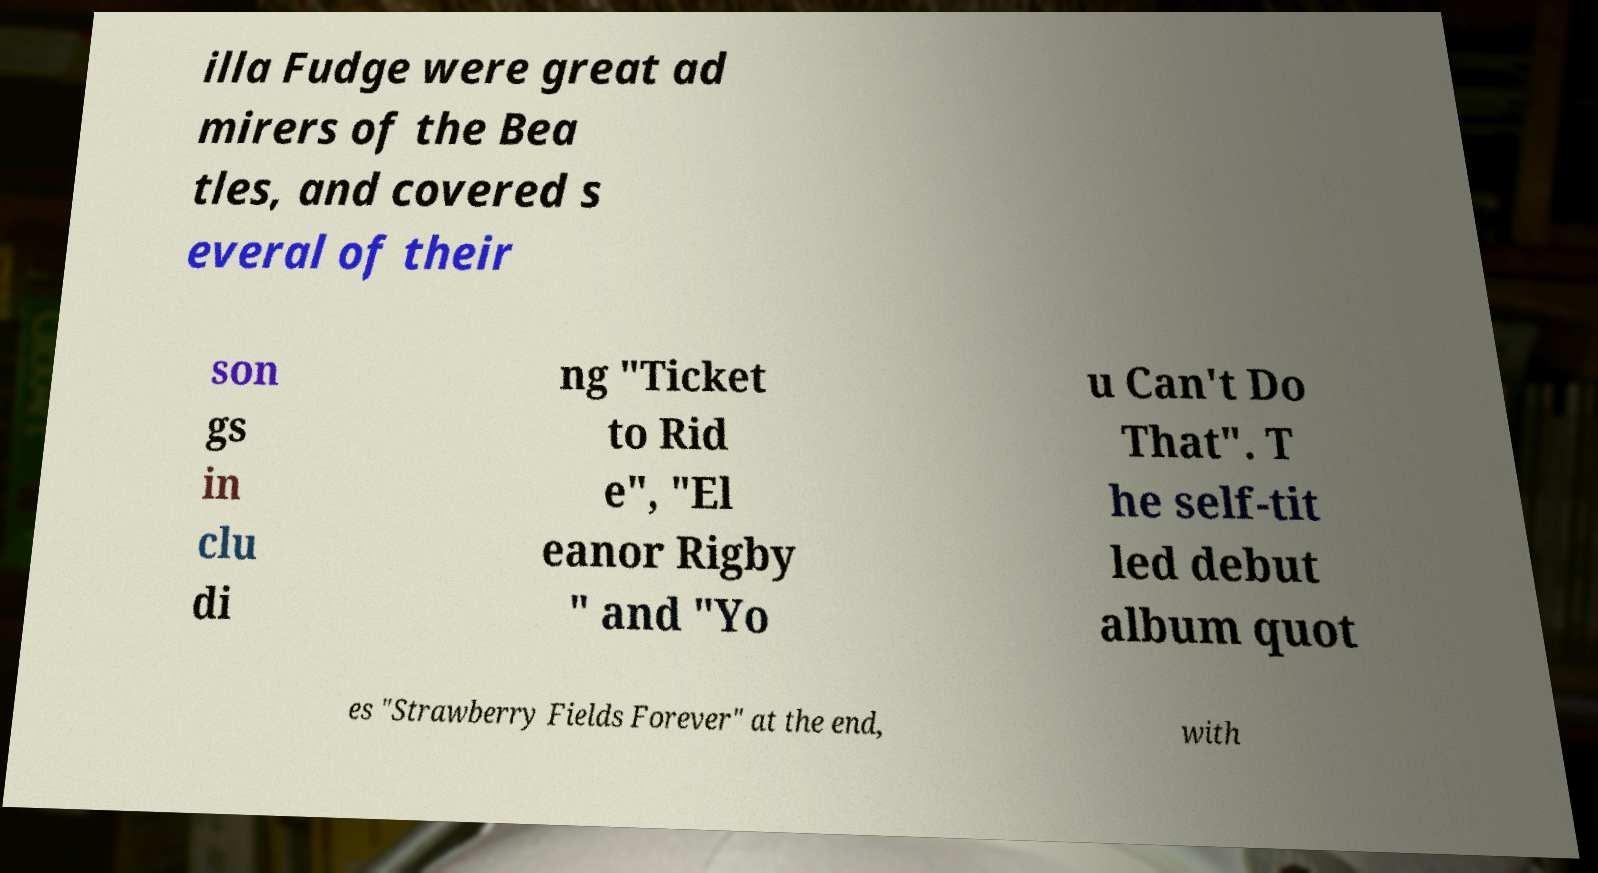Can you read and provide the text displayed in the image?This photo seems to have some interesting text. Can you extract and type it out for me? illa Fudge were great ad mirers of the Bea tles, and covered s everal of their son gs in clu di ng "Ticket to Rid e", "El eanor Rigby " and "Yo u Can't Do That". T he self-tit led debut album quot es "Strawberry Fields Forever" at the end, with 